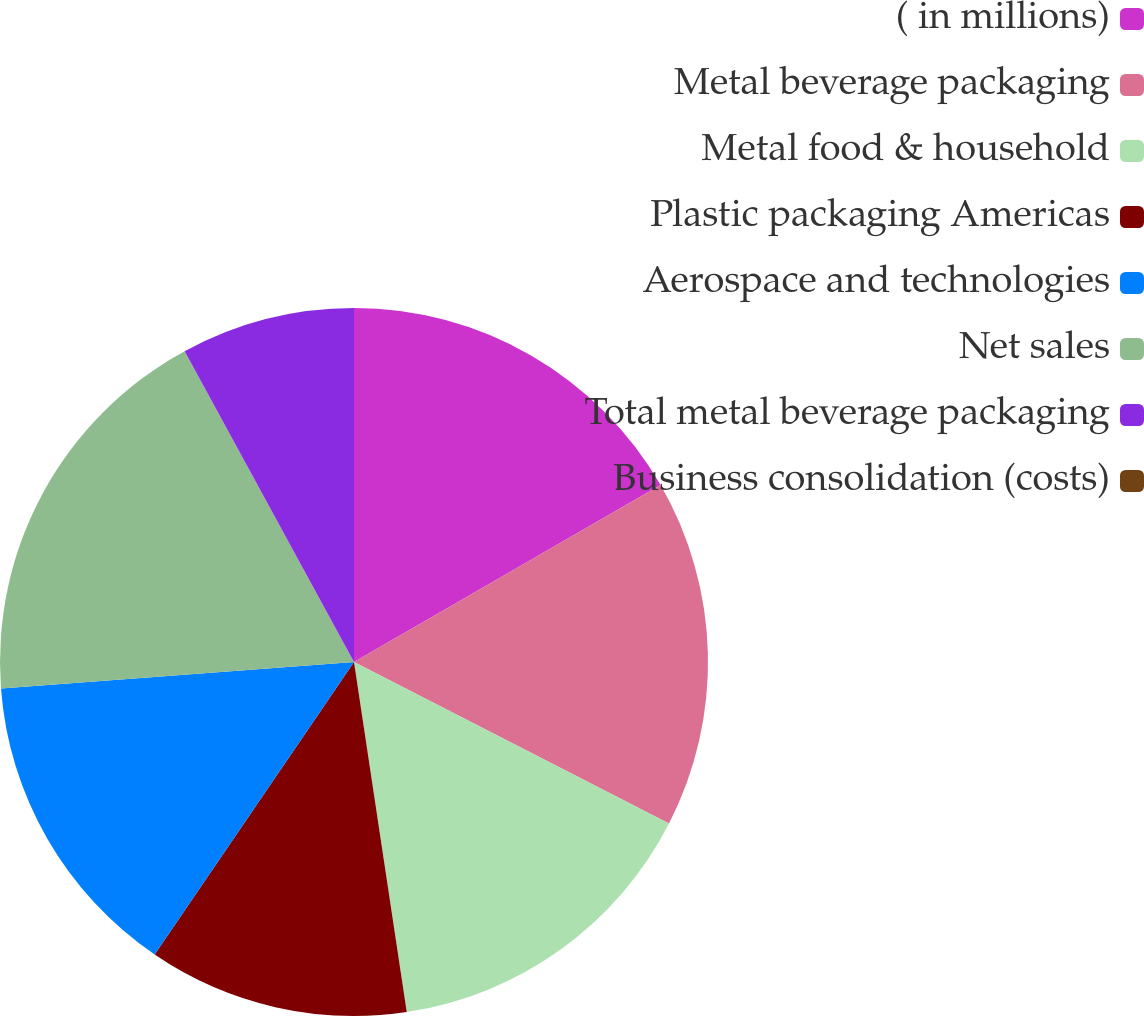Convert chart to OTSL. <chart><loc_0><loc_0><loc_500><loc_500><pie_chart><fcel>( in millions)<fcel>Metal beverage packaging<fcel>Metal food & household<fcel>Plastic packaging Americas<fcel>Aerospace and technologies<fcel>Net sales<fcel>Total metal beverage packaging<fcel>Business consolidation (costs)<nl><fcel>16.67%<fcel>15.87%<fcel>15.08%<fcel>11.9%<fcel>14.29%<fcel>18.25%<fcel>7.94%<fcel>0.0%<nl></chart> 